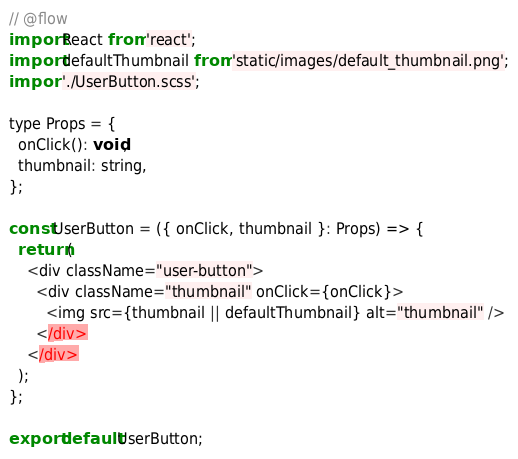<code> <loc_0><loc_0><loc_500><loc_500><_JavaScript_>// @flow
import React from 'react';
import defaultThumbnail from 'static/images/default_thumbnail.png';
import './UserButton.scss';

type Props = {
  onClick(): void,
  thumbnail: string,
};

const UserButton = ({ onClick, thumbnail }: Props) => {
  return (
    <div className="user-button">
      <div className="thumbnail" onClick={onClick}>
        <img src={thumbnail || defaultThumbnail} alt="thumbnail" />
      </div>
    </div>
  );
};

export default UserButton;
</code> 